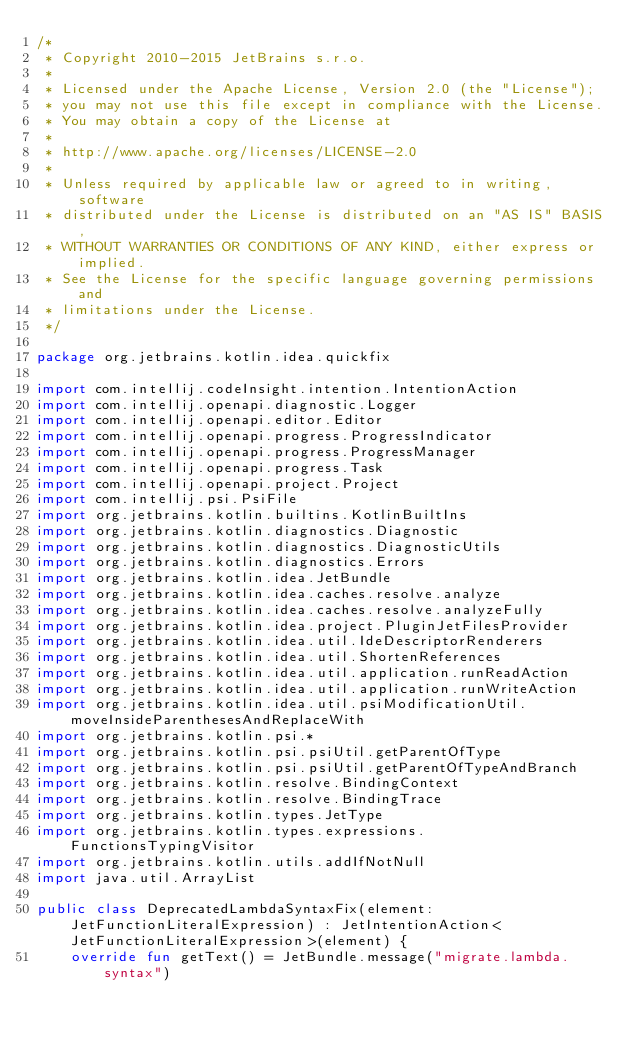Convert code to text. <code><loc_0><loc_0><loc_500><loc_500><_Kotlin_>/*
 * Copyright 2010-2015 JetBrains s.r.o.
 *
 * Licensed under the Apache License, Version 2.0 (the "License");
 * you may not use this file except in compliance with the License.
 * You may obtain a copy of the License at
 *
 * http://www.apache.org/licenses/LICENSE-2.0
 *
 * Unless required by applicable law or agreed to in writing, software
 * distributed under the License is distributed on an "AS IS" BASIS,
 * WITHOUT WARRANTIES OR CONDITIONS OF ANY KIND, either express or implied.
 * See the License for the specific language governing permissions and
 * limitations under the License.
 */

package org.jetbrains.kotlin.idea.quickfix

import com.intellij.codeInsight.intention.IntentionAction
import com.intellij.openapi.diagnostic.Logger
import com.intellij.openapi.editor.Editor
import com.intellij.openapi.progress.ProgressIndicator
import com.intellij.openapi.progress.ProgressManager
import com.intellij.openapi.progress.Task
import com.intellij.openapi.project.Project
import com.intellij.psi.PsiFile
import org.jetbrains.kotlin.builtins.KotlinBuiltIns
import org.jetbrains.kotlin.diagnostics.Diagnostic
import org.jetbrains.kotlin.diagnostics.DiagnosticUtils
import org.jetbrains.kotlin.diagnostics.Errors
import org.jetbrains.kotlin.idea.JetBundle
import org.jetbrains.kotlin.idea.caches.resolve.analyze
import org.jetbrains.kotlin.idea.caches.resolve.analyzeFully
import org.jetbrains.kotlin.idea.project.PluginJetFilesProvider
import org.jetbrains.kotlin.idea.util.IdeDescriptorRenderers
import org.jetbrains.kotlin.idea.util.ShortenReferences
import org.jetbrains.kotlin.idea.util.application.runReadAction
import org.jetbrains.kotlin.idea.util.application.runWriteAction
import org.jetbrains.kotlin.idea.util.psiModificationUtil.moveInsideParenthesesAndReplaceWith
import org.jetbrains.kotlin.psi.*
import org.jetbrains.kotlin.psi.psiUtil.getParentOfType
import org.jetbrains.kotlin.psi.psiUtil.getParentOfTypeAndBranch
import org.jetbrains.kotlin.resolve.BindingContext
import org.jetbrains.kotlin.resolve.BindingTrace
import org.jetbrains.kotlin.types.JetType
import org.jetbrains.kotlin.types.expressions.FunctionsTypingVisitor
import org.jetbrains.kotlin.utils.addIfNotNull
import java.util.ArrayList

public class DeprecatedLambdaSyntaxFix(element: JetFunctionLiteralExpression) : JetIntentionAction<JetFunctionLiteralExpression>(element) {
    override fun getText() = JetBundle.message("migrate.lambda.syntax")</code> 